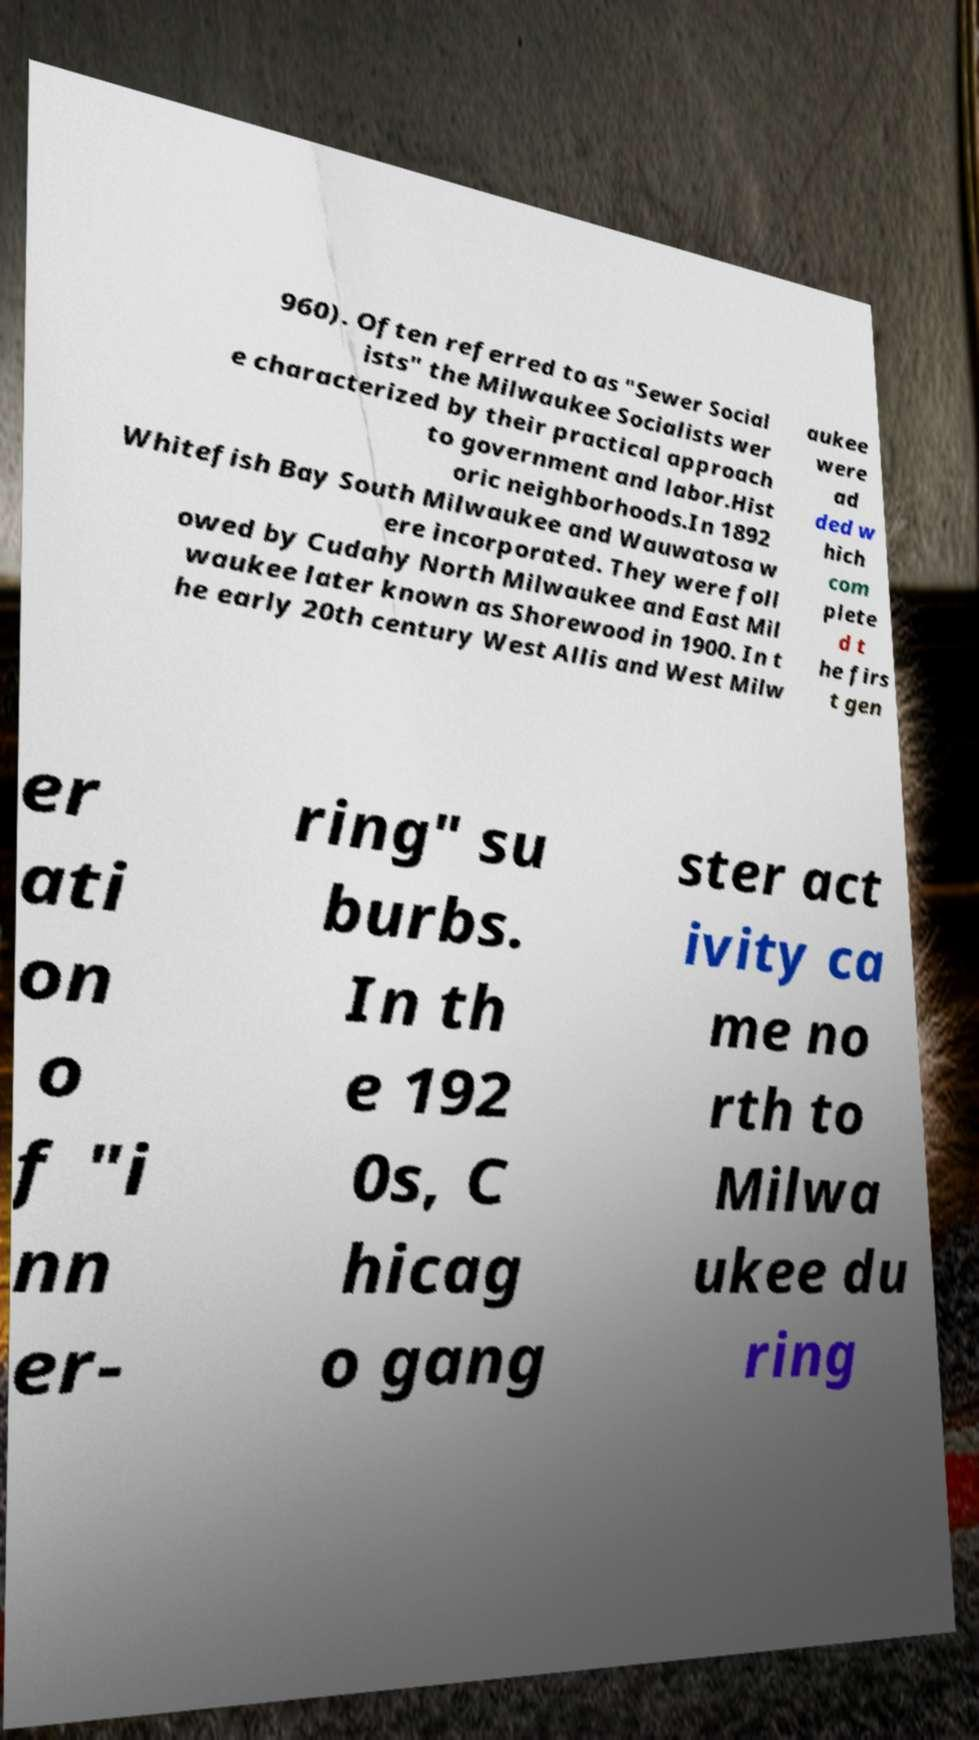Can you read and provide the text displayed in the image?This photo seems to have some interesting text. Can you extract and type it out for me? 960). Often referred to as "Sewer Social ists" the Milwaukee Socialists wer e characterized by their practical approach to government and labor.Hist oric neighborhoods.In 1892 Whitefish Bay South Milwaukee and Wauwatosa w ere incorporated. They were foll owed by Cudahy North Milwaukee and East Mil waukee later known as Shorewood in 1900. In t he early 20th century West Allis and West Milw aukee were ad ded w hich com plete d t he firs t gen er ati on o f "i nn er- ring" su burbs. In th e 192 0s, C hicag o gang ster act ivity ca me no rth to Milwa ukee du ring 